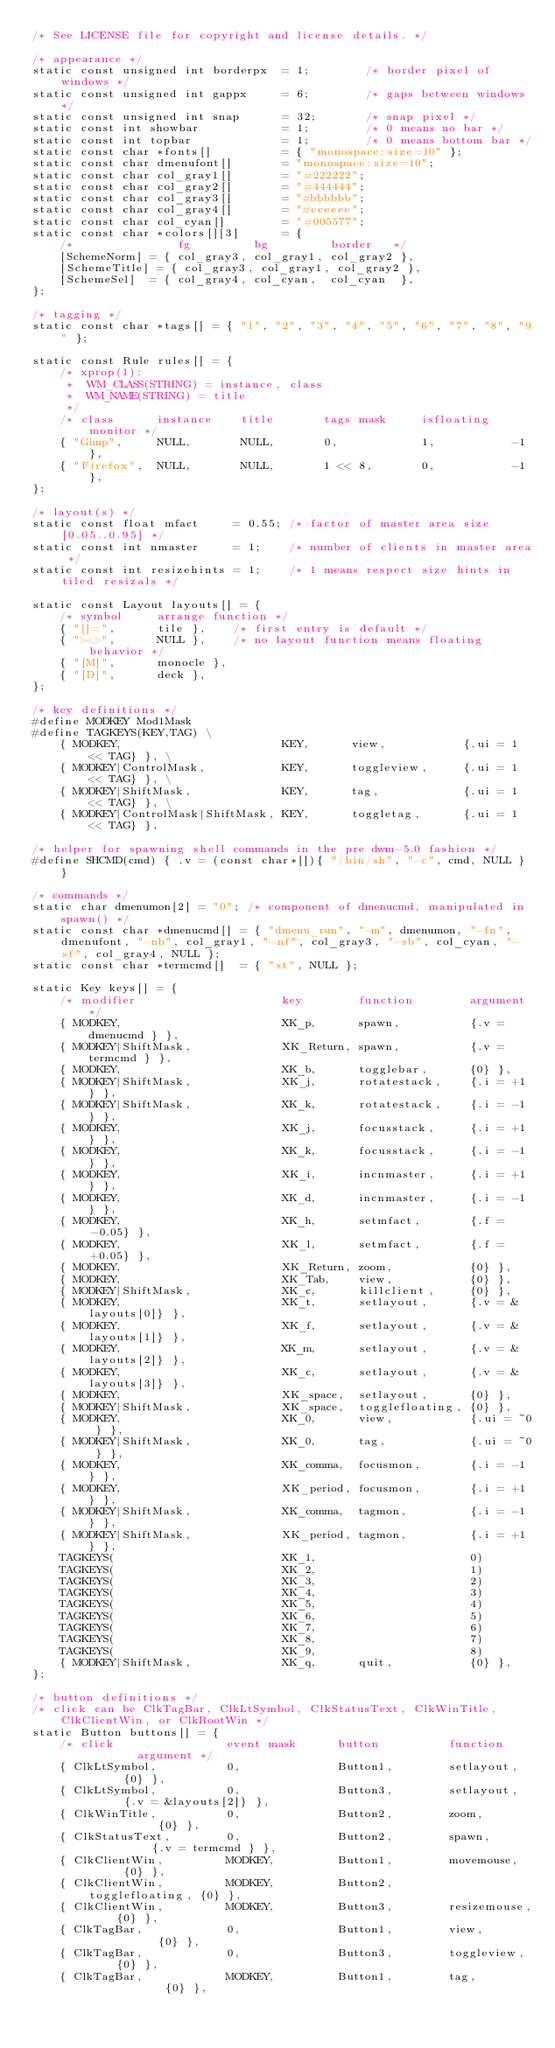<code> <loc_0><loc_0><loc_500><loc_500><_C_>/* See LICENSE file for copyright and license details. */

/* appearance */
static const unsigned int borderpx  = 1;        /* border pixel of windows */
static const unsigned int gappx     = 6;        /* gaps between windows */
static const unsigned int snap      = 32;       /* snap pixel */
static const int showbar            = 1;        /* 0 means no bar */
static const int topbar             = 1;        /* 0 means bottom bar */
static const char *fonts[]          = { "monospace:size=10" };
static const char dmenufont[]       = "monospace:size=10";
static const char col_gray1[]       = "#222222";
static const char col_gray2[]       = "#444444";
static const char col_gray3[]       = "#bbbbbb";
static const char col_gray4[]       = "#eeeeee";
static const char col_cyan[]        = "#005577";
static const char *colors[][3]      = {
	/*               fg         bg         border   */
	[SchemeNorm] = { col_gray3, col_gray1, col_gray2 },
	[SchemeTitle] = { col_gray3, col_gray1, col_gray2 },
	[SchemeSel]  = { col_gray4, col_cyan,  col_cyan  },
};

/* tagging */
static const char *tags[] = { "1", "2", "3", "4", "5", "6", "7", "8", "9" };

static const Rule rules[] = {
	/* xprop(1):
	 *	WM_CLASS(STRING) = instance, class
	 *	WM_NAME(STRING) = title
	 */
	/* class      instance    title       tags mask     isfloating   monitor */
	{ "Gimp",     NULL,       NULL,       0,            1,           -1 },
	{ "Firefox",  NULL,       NULL,       1 << 8,       0,           -1 },
};

/* layout(s) */
static const float mfact     = 0.55; /* factor of master area size [0.05..0.95] */
static const int nmaster     = 1;    /* number of clients in master area */
static const int resizehints = 1;    /* 1 means respect size hints in tiled resizals */

static const Layout layouts[] = {
	/* symbol     arrange function */
	{ "[]=",      tile },    /* first entry is default */
	{ "><>",      NULL },    /* no layout function means floating behavior */
	{ "[M]",      monocle },
	{ "[D]",      deck },
};

/* key definitions */
#define MODKEY Mod1Mask
#define TAGKEYS(KEY,TAG) \
	{ MODKEY,                       KEY,      view,           {.ui = 1 << TAG} }, \
	{ MODKEY|ControlMask,           KEY,      toggleview,     {.ui = 1 << TAG} }, \
	{ MODKEY|ShiftMask,             KEY,      tag,            {.ui = 1 << TAG} }, \
	{ MODKEY|ControlMask|ShiftMask, KEY,      toggletag,      {.ui = 1 << TAG} },

/* helper for spawning shell commands in the pre dwm-5.0 fashion */
#define SHCMD(cmd) { .v = (const char*[]){ "/bin/sh", "-c", cmd, NULL } }

/* commands */
static char dmenumon[2] = "0"; /* component of dmenucmd, manipulated in spawn() */
static const char *dmenucmd[] = { "dmenu_run", "-m", dmenumon, "-fn", dmenufont, "-nb", col_gray1, "-nf", col_gray3, "-sb", col_cyan, "-sf", col_gray4, NULL };
static const char *termcmd[]  = { "st", NULL };

static Key keys[] = {
	/* modifier                     key        function        argument */
	{ MODKEY,                       XK_p,      spawn,          {.v = dmenucmd } },
	{ MODKEY|ShiftMask,             XK_Return, spawn,          {.v = termcmd } },
	{ MODKEY,                       XK_b,      togglebar,      {0} },
	{ MODKEY|ShiftMask,             XK_j,      rotatestack,    {.i = +1 } },
	{ MODKEY|ShiftMask,             XK_k,      rotatestack,    {.i = -1 } },
	{ MODKEY,                       XK_j,      focusstack,     {.i = +1 } },
	{ MODKEY,                       XK_k,      focusstack,     {.i = -1 } },
	{ MODKEY,                       XK_i,      incnmaster,     {.i = +1 } },
	{ MODKEY,                       XK_d,      incnmaster,     {.i = -1 } },
	{ MODKEY,                       XK_h,      setmfact,       {.f = -0.05} },
	{ MODKEY,                       XK_l,      setmfact,       {.f = +0.05} },
	{ MODKEY,                       XK_Return, zoom,           {0} },
	{ MODKEY,                       XK_Tab,    view,           {0} },
	{ MODKEY|ShiftMask,             XK_c,      killclient,     {0} },
	{ MODKEY,                       XK_t,      setlayout,      {.v = &layouts[0]} },
	{ MODKEY,                       XK_f,      setlayout,      {.v = &layouts[1]} },
	{ MODKEY,                       XK_m,      setlayout,      {.v = &layouts[2]} },
	{ MODKEY,                       XK_c,      setlayout,      {.v = &layouts[3]} },
	{ MODKEY,                       XK_space,  setlayout,      {0} },
	{ MODKEY|ShiftMask,             XK_space,  togglefloating, {0} },
	{ MODKEY,                       XK_0,      view,           {.ui = ~0 } },
	{ MODKEY|ShiftMask,             XK_0,      tag,            {.ui = ~0 } },
	{ MODKEY,                       XK_comma,  focusmon,       {.i = -1 } },
	{ MODKEY,                       XK_period, focusmon,       {.i = +1 } },
	{ MODKEY|ShiftMask,             XK_comma,  tagmon,         {.i = -1 } },
	{ MODKEY|ShiftMask,             XK_period, tagmon,         {.i = +1 } },
	TAGKEYS(                        XK_1,                      0)
	TAGKEYS(                        XK_2,                      1)
	TAGKEYS(                        XK_3,                      2)
	TAGKEYS(                        XK_4,                      3)
	TAGKEYS(                        XK_5,                      4)
	TAGKEYS(                        XK_6,                      5)
	TAGKEYS(                        XK_7,                      6)
	TAGKEYS(                        XK_8,                      7)
	TAGKEYS(                        XK_9,                      8)
	{ MODKEY|ShiftMask,             XK_q,      quit,           {0} },
};

/* button definitions */
/* click can be ClkTagBar, ClkLtSymbol, ClkStatusText, ClkWinTitle, ClkClientWin, or ClkRootWin */
static Button buttons[] = {
	/* click                event mask      button          function        argument */
	{ ClkLtSymbol,          0,              Button1,        setlayout,      {0} },
	{ ClkLtSymbol,          0,              Button3,        setlayout,      {.v = &layouts[2]} },
	{ ClkWinTitle,          0,              Button2,        zoom,           {0} },
	{ ClkStatusText,        0,              Button2,        spawn,          {.v = termcmd } },
	{ ClkClientWin,         MODKEY,         Button1,        movemouse,      {0} },
	{ ClkClientWin,         MODKEY,         Button2,        togglefloating, {0} },
	{ ClkClientWin,         MODKEY,         Button3,        resizemouse,    {0} },
	{ ClkTagBar,            0,              Button1,        view,           {0} },
	{ ClkTagBar,            0,              Button3,        toggleview,     {0} },
	{ ClkTagBar,            MODKEY,         Button1,        tag,            {0} },</code> 